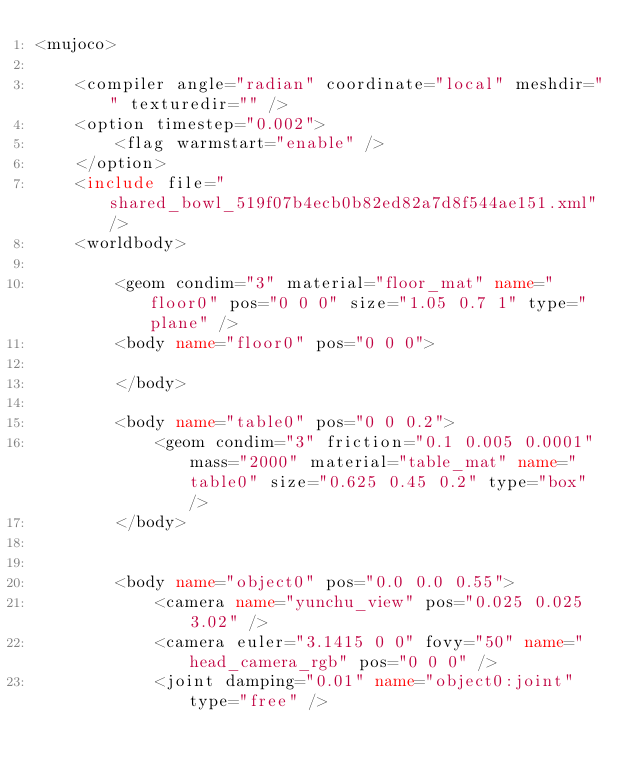Convert code to text. <code><loc_0><loc_0><loc_500><loc_500><_XML_><mujoco>

    <compiler angle="radian" coordinate="local" meshdir="" texturedir="" />
    <option timestep="0.002">
        <flag warmstart="enable" />
    </option>
    <include file="shared_bowl_519f07b4ecb0b82ed82a7d8f544ae151.xml" />
    <worldbody>

        <geom condim="3" material="floor_mat" name="floor0" pos="0 0 0" size="1.05 0.7 1" type="plane" />
        <body name="floor0" pos="0 0 0">
            
        </body>

        <body name="table0" pos="0 0 0.2">
            <geom condim="3" friction="0.1 0.005 0.0001" mass="2000" material="table_mat" name="table0" size="0.625 0.45 0.2" type="box" />
        </body>
        

        <body name="object0" pos="0.0 0.0 0.55">
            <camera name="yunchu_view" pos="0.025 0.025 3.02" />
            <camera euler="3.1415 0 0" fovy="50" name="head_camera_rgb" pos="0 0 0" />
            <joint damping="0.01" name="object0:joint" type="free" />
</code> 